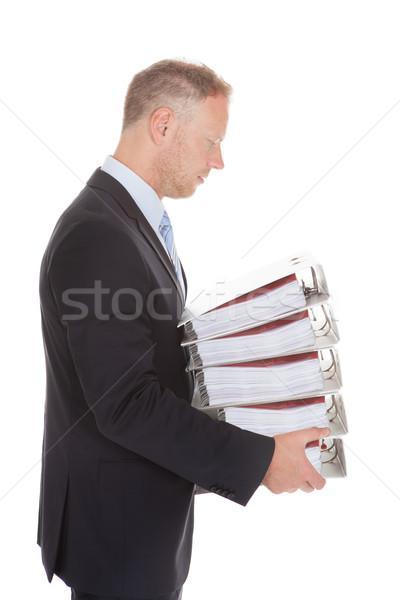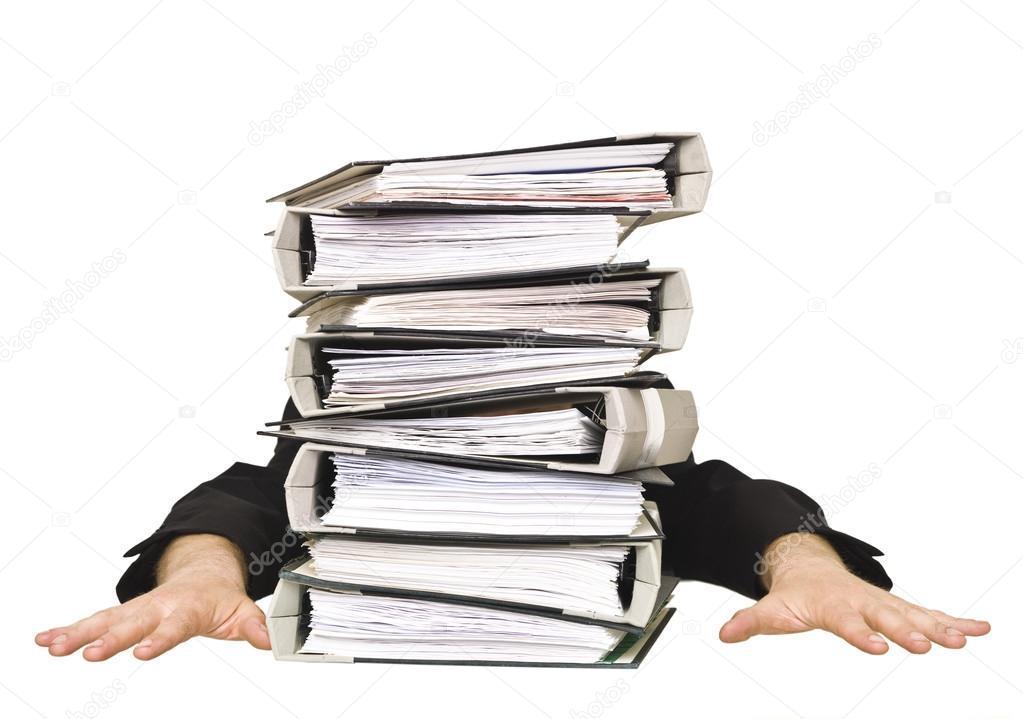The first image is the image on the left, the second image is the image on the right. For the images displayed, is the sentence "A man's face is visible near a stack of books." factually correct? Answer yes or no. Yes. The first image is the image on the left, the second image is the image on the right. For the images shown, is this caption "An image shows only arms in black sleeves sticking out from behind a stack of binders, all with open ends showing." true? Answer yes or no. Yes. 